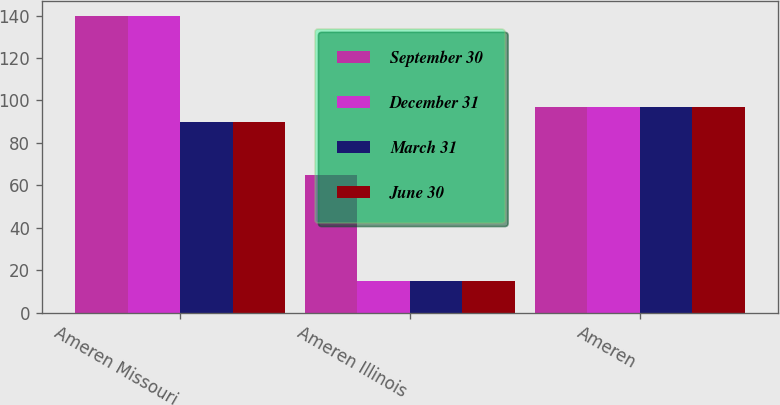Convert chart to OTSL. <chart><loc_0><loc_0><loc_500><loc_500><stacked_bar_chart><ecel><fcel>Ameren Missouri<fcel>Ameren Illinois<fcel>Ameren<nl><fcel>September 30<fcel>140<fcel>65<fcel>97<nl><fcel>December 31<fcel>140<fcel>15<fcel>97<nl><fcel>March 31<fcel>90<fcel>15<fcel>97<nl><fcel>June 30<fcel>90<fcel>15<fcel>97<nl></chart> 